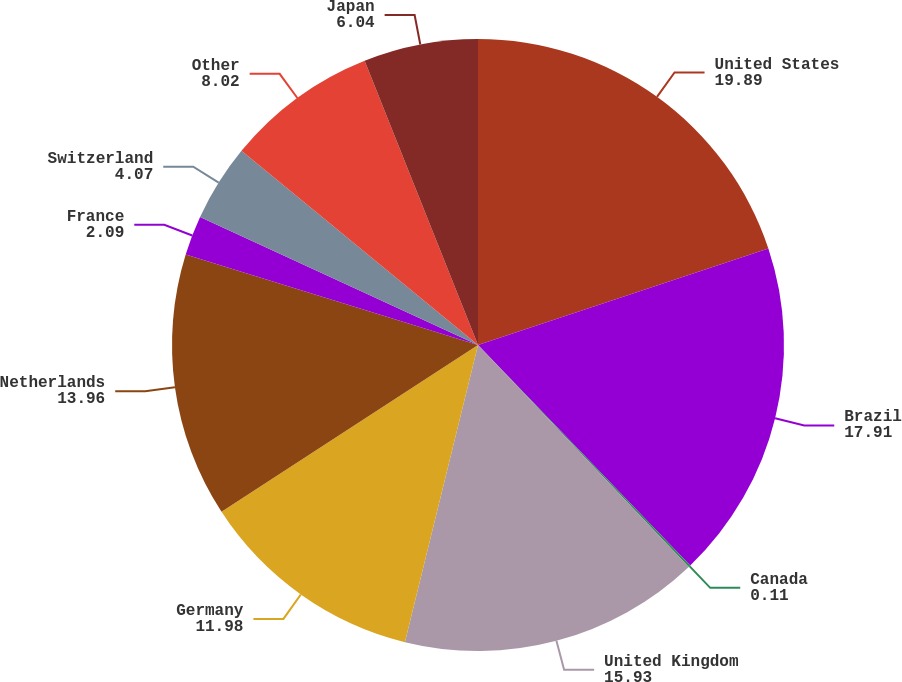<chart> <loc_0><loc_0><loc_500><loc_500><pie_chart><fcel>United States<fcel>Brazil<fcel>Canada<fcel>United Kingdom<fcel>Germany<fcel>Netherlands<fcel>France<fcel>Switzerland<fcel>Other<fcel>Japan<nl><fcel>19.89%<fcel>17.91%<fcel>0.11%<fcel>15.93%<fcel>11.98%<fcel>13.96%<fcel>2.09%<fcel>4.07%<fcel>8.02%<fcel>6.04%<nl></chart> 